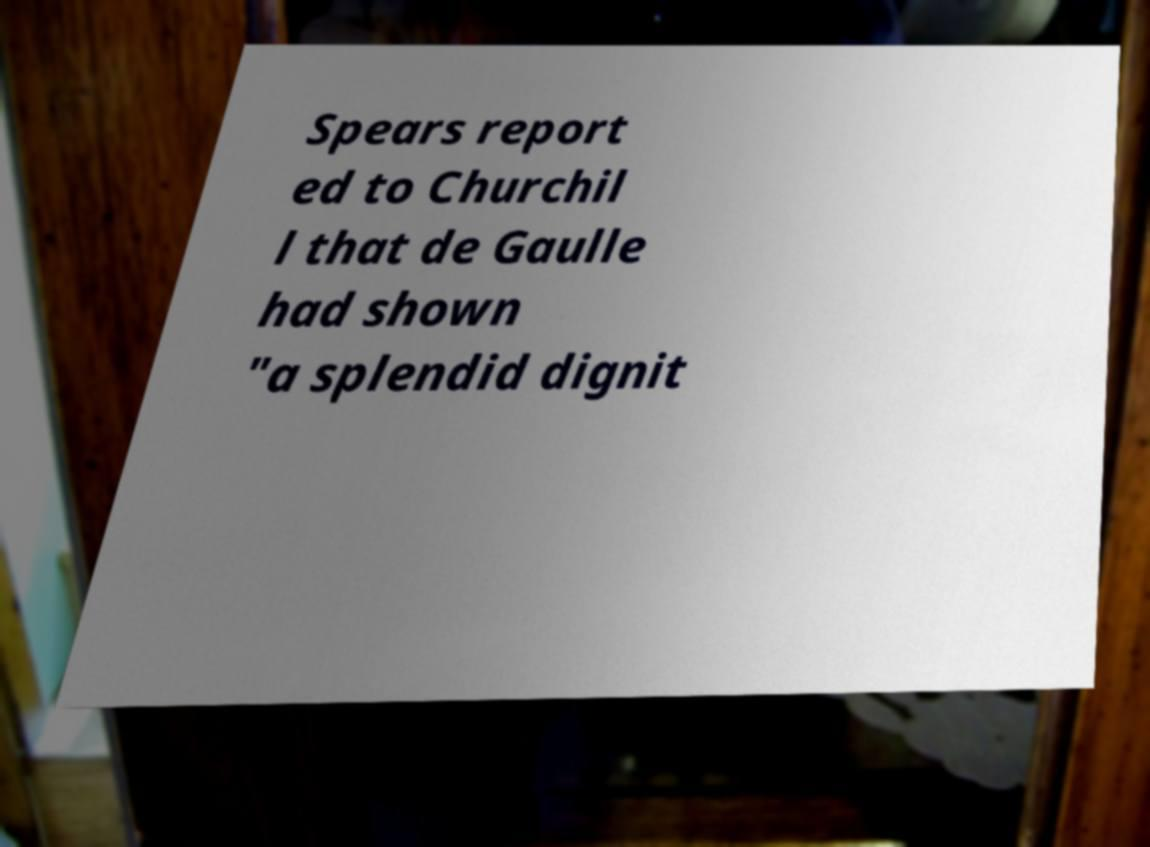Could you extract and type out the text from this image? Spears report ed to Churchil l that de Gaulle had shown "a splendid dignit 